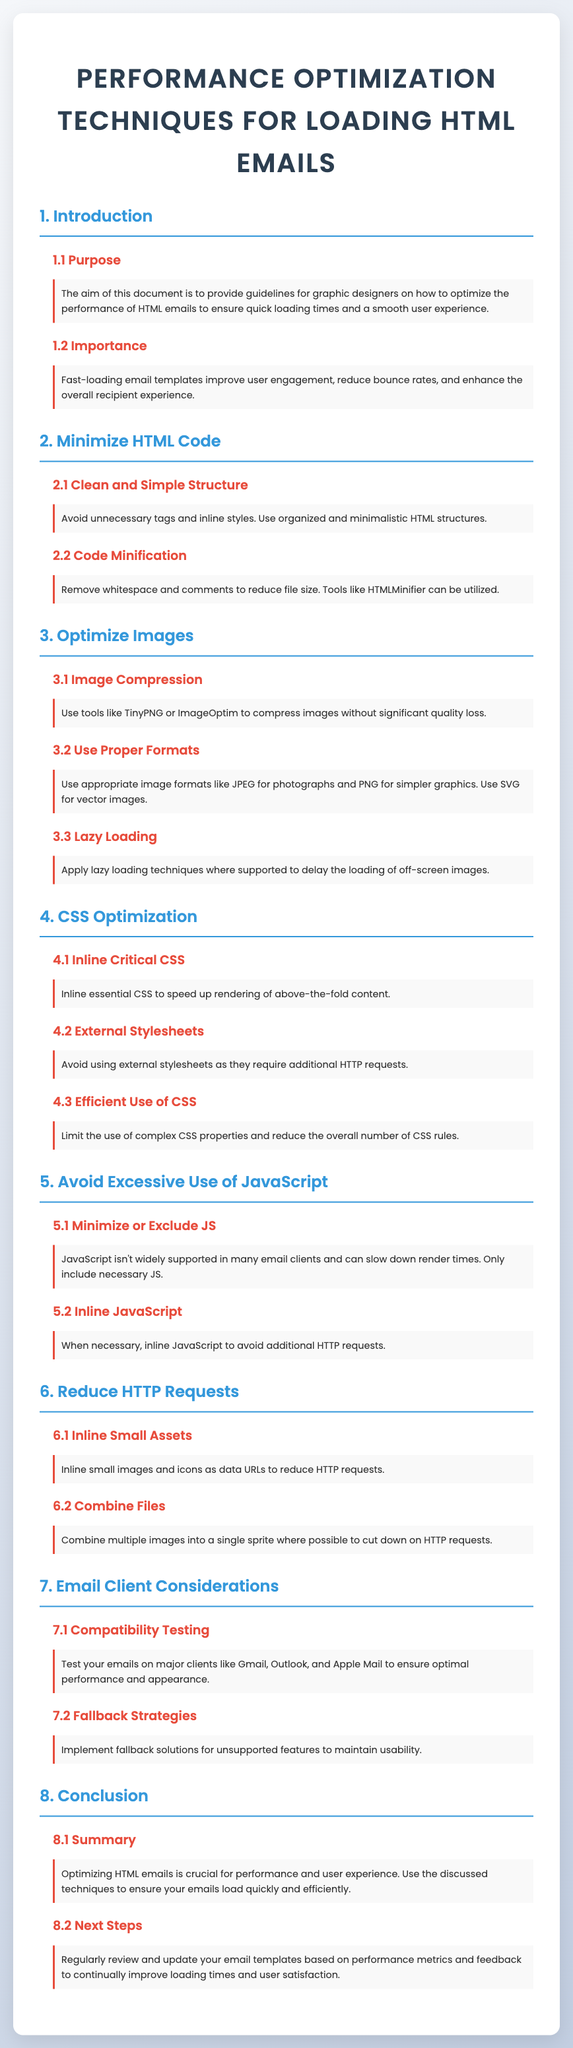what is the purpose of the document? The purpose of the document is to provide guidelines for graphic designers on how to optimize the performance of HTML emails to ensure quick loading times and a smooth user experience.
Answer: to provide guidelines for graphic designers what is a benefit of fast-loading email templates? Fast-loading email templates improve user engagement, reduce bounce rates, and enhance the overall recipient experience.
Answer: improve user engagement which tool can be used for code minification? The document suggests using HTMLMinifier as a tool for code minification, which removes whitespace and comments to reduce file size.
Answer: HTMLMinifier what image format is recommended for photographs? The appropriate image format for photographs as mentioned in the document is JPEG.
Answer: JPEG how should critical CSS be managed for optimization? To speed up rendering of above-the-fold content, essential CSS should be inlined as per the document's recommendations.
Answer: inline essential CSS what is the maximum number of sections in the document? The document has eight main sections, each addressing different performance optimization techniques for HTML emails.
Answer: eight what is a suggested strategy for testing email compatibility? The document advises to test emails on major clients like Gmail, Outlook, and Apple Mail to ensure optimal performance and appearance.
Answer: test on major clients what is mentioned as a fallback strategy in the document? The document suggests implementing fallback solutions for unsupported features to maintain usability in various email clients.
Answer: fallback solutions 